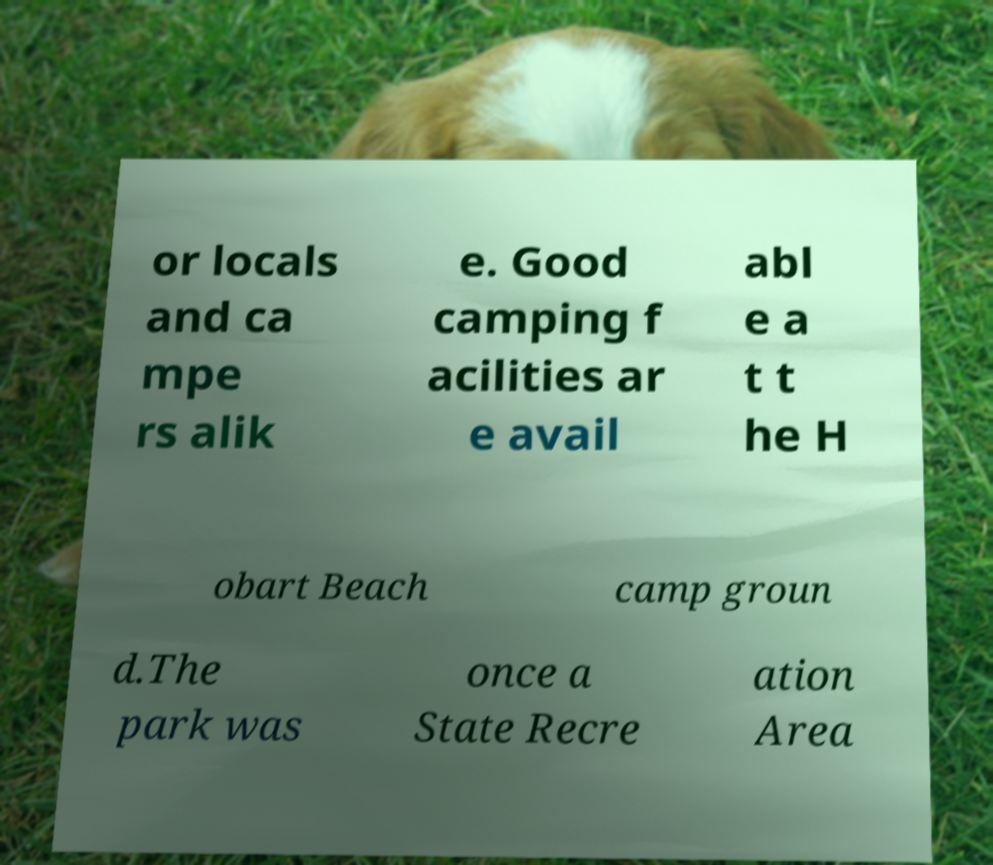Please identify and transcribe the text found in this image. or locals and ca mpe rs alik e. Good camping f acilities ar e avail abl e a t t he H obart Beach camp groun d.The park was once a State Recre ation Area 